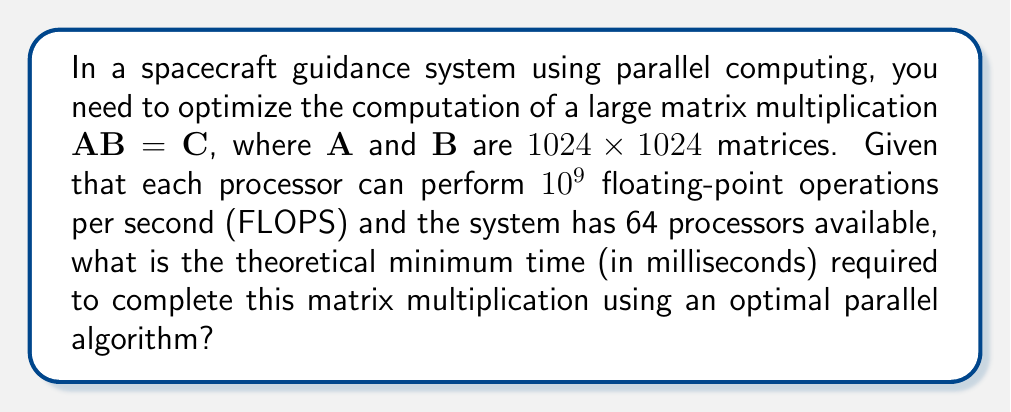Give your solution to this math problem. Let's approach this step-by-step:

1) First, we need to calculate the total number of floating-point operations required for the matrix multiplication:
   - For an $n \times n$ matrix multiplication, the number of operations is $2n^3 - n^2$
   - In this case, $n = 1024$
   - Total operations = $2(1024^3) - 1024^2 = 2,147,385,344$

2) Now, let's consider the parallel processing capability:
   - Number of processors = 64
   - Each processor can perform $10^9$ FLOPS

3) If we distribute the workload evenly among all processors, each processor will handle:
   $\frac{2,147,385,344}{64} = 33,553,208$ operations

4) The time taken by each processor will be:
   $\frac{33,553,208}{10^9} = 0.033553208$ seconds

5) Convert this to milliseconds:
   $0.033553208 \times 1000 = 33.553208$ milliseconds

This is the theoretical minimum time, assuming perfect load balancing and no communication overhead between processors.
Answer: 33.55 ms 